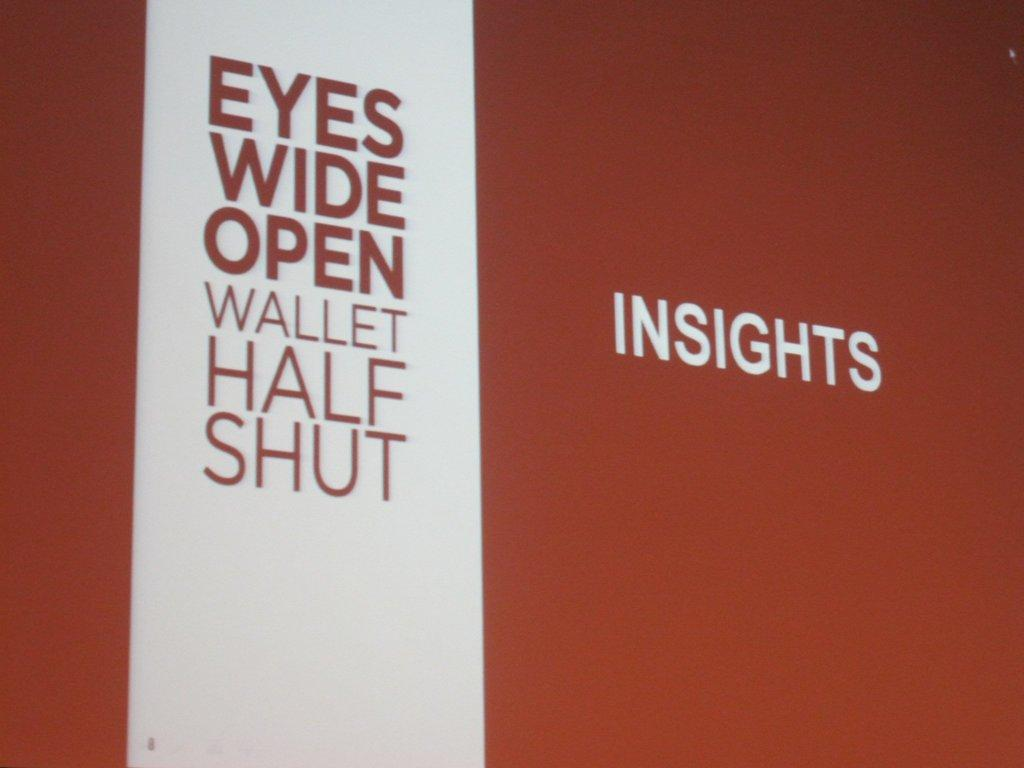<image>
Create a compact narrative representing the image presented. A sign says Eyes Wide Open and Insights. 